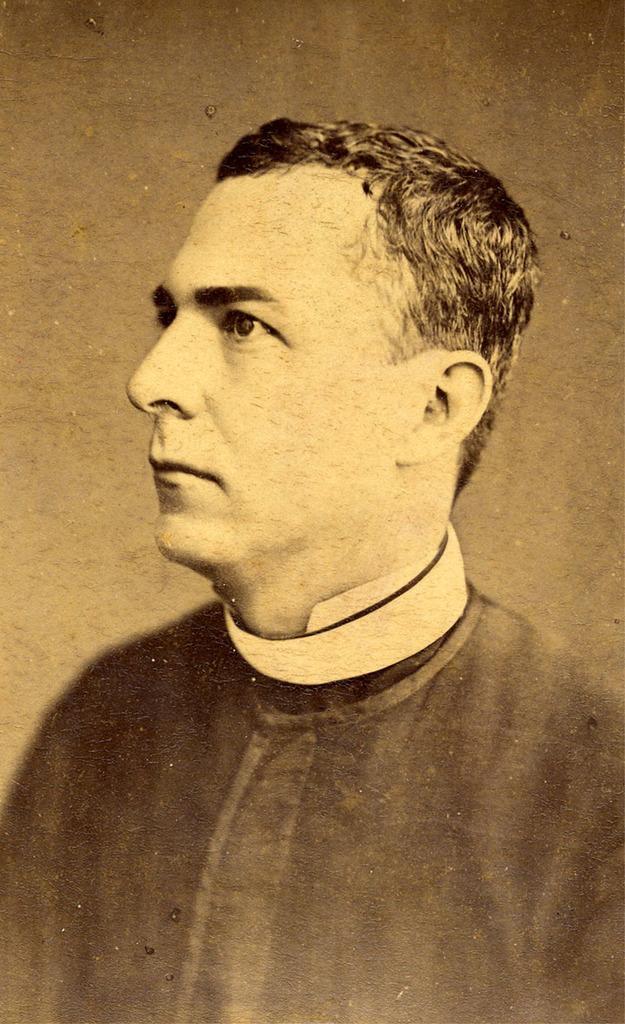Could you give a brief overview of what you see in this image? In the image we can see the poster, in the poster we can see the picture of a man wearing clothes. 